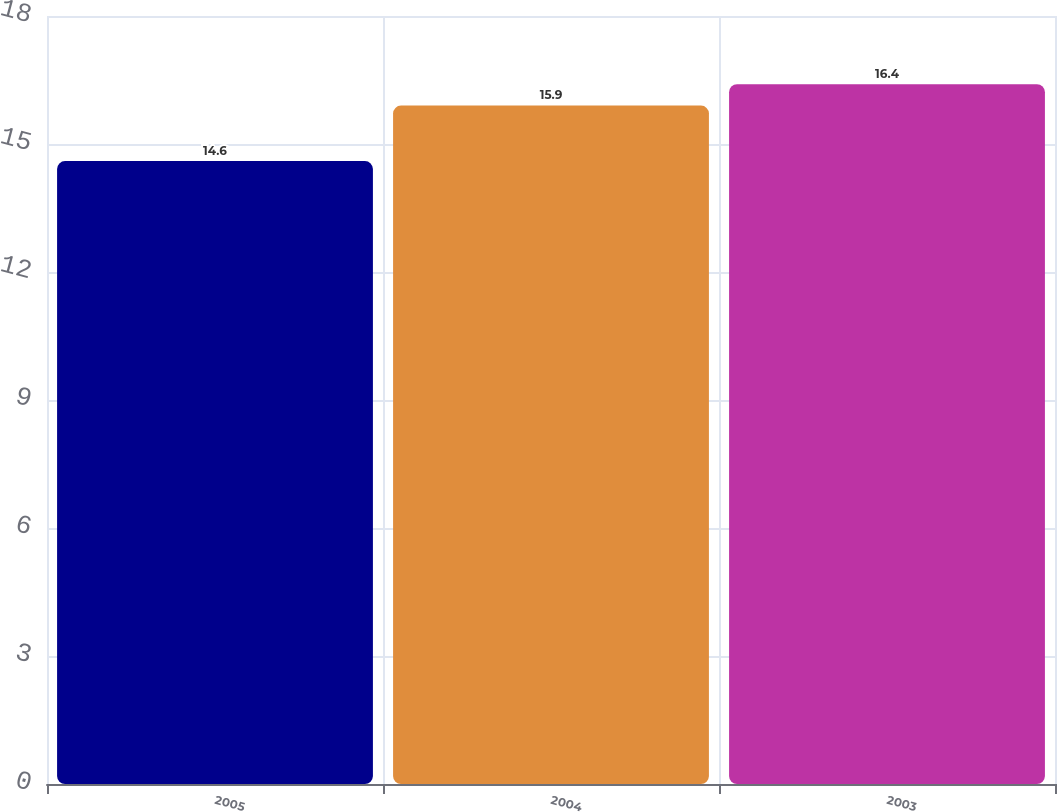Convert chart to OTSL. <chart><loc_0><loc_0><loc_500><loc_500><bar_chart><fcel>2005<fcel>2004<fcel>2003<nl><fcel>14.6<fcel>15.9<fcel>16.4<nl></chart> 